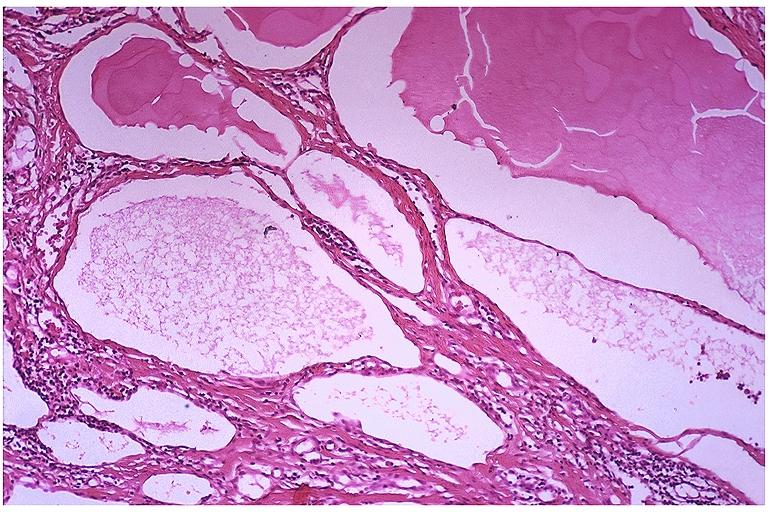s endocervical polyp present?
Answer the question using a single word or phrase. No 